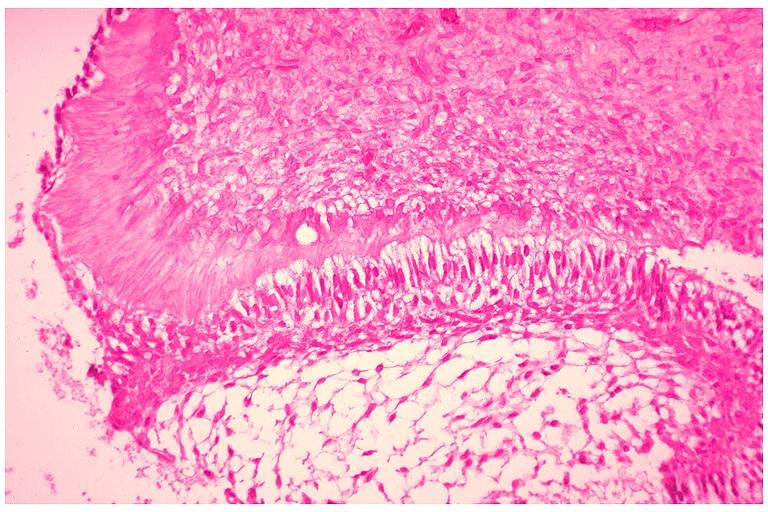s oral present?
Answer the question using a single word or phrase. Yes 